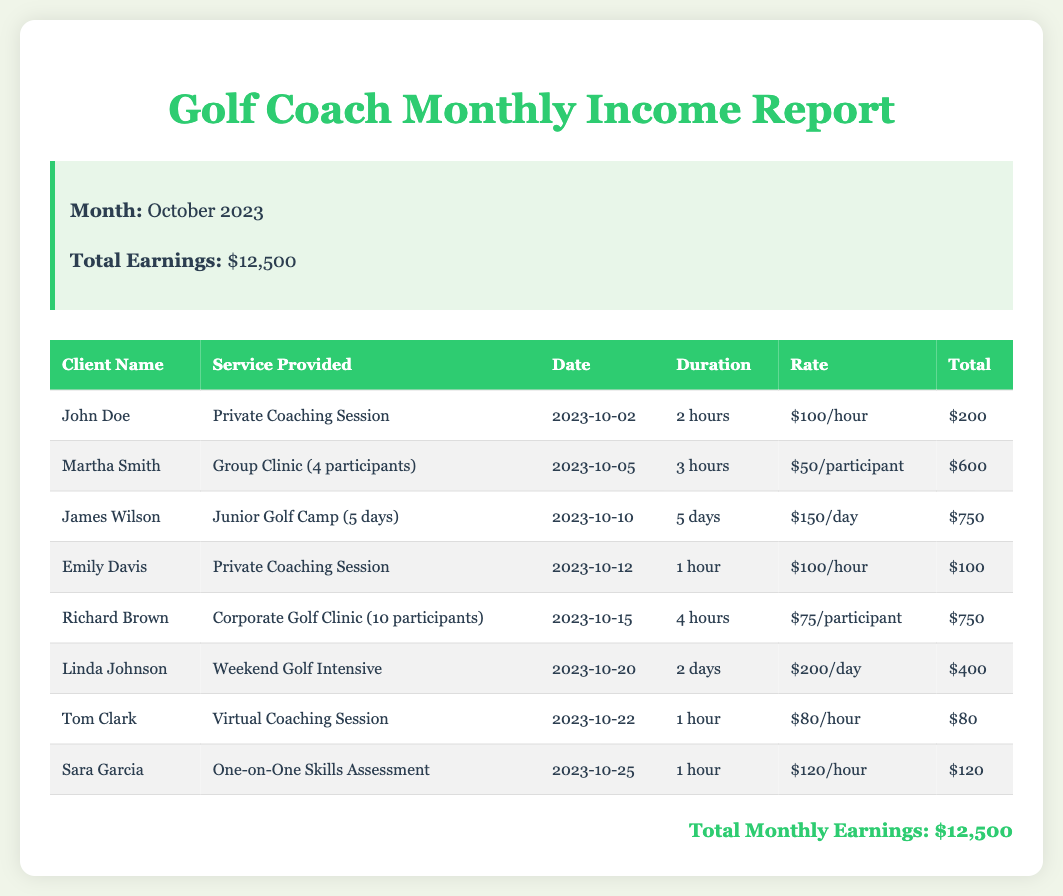What is the total earnings for October 2023? The total earnings for October 2023 are explicitly stated in the summary section of the report.
Answer: $12,500 Who provided a Private Coaching Session on October 2, 2023? The document lists the names of clients attending various sessions, including the Private Coaching Session on the specified date.
Answer: John Doe What service did Martha Smith participate in? The document details the services provided to each client, including Martha Smith's participation.
Answer: Group Clinic (4 participants) How much did Richard Brown earn from his Corporate Golf Clinic? The earnings from each client's service are listed, allowing us to retrieve Richard Brown's earnings from his service.
Answer: $750 How many hours did Emily Davis's session last? The document provides the duration of each session, including the duration of Emily Davis's session.
Answer: 1 hour What was the rate for the Virtual Coaching Session provided to Tom Clark? The document specifies the rate charged for Tom Clark's Virtual Coaching Session.
Answer: $80/hour Which service had the highest total earnings? By comparing the total earnings listed, we can determine which service accrued the most earnings.
Answer: Group Clinic (4 participants) Who had a session on October 25, 2023? The table includes the dates for each session, helping us identify the client who had a session on the specified date.
Answer: Sara Garcia What is the total amount earned from Private Coaching Sessions? The total earnings from Private Coaching Sessions can be calculated based on the relevant entries in the table.
Answer: $300 How many clients participated in the Corporate Golf Clinic? The document specifies the number of participants in each service provided, including the Corporate Golf Clinic.
Answer: 10 participants 